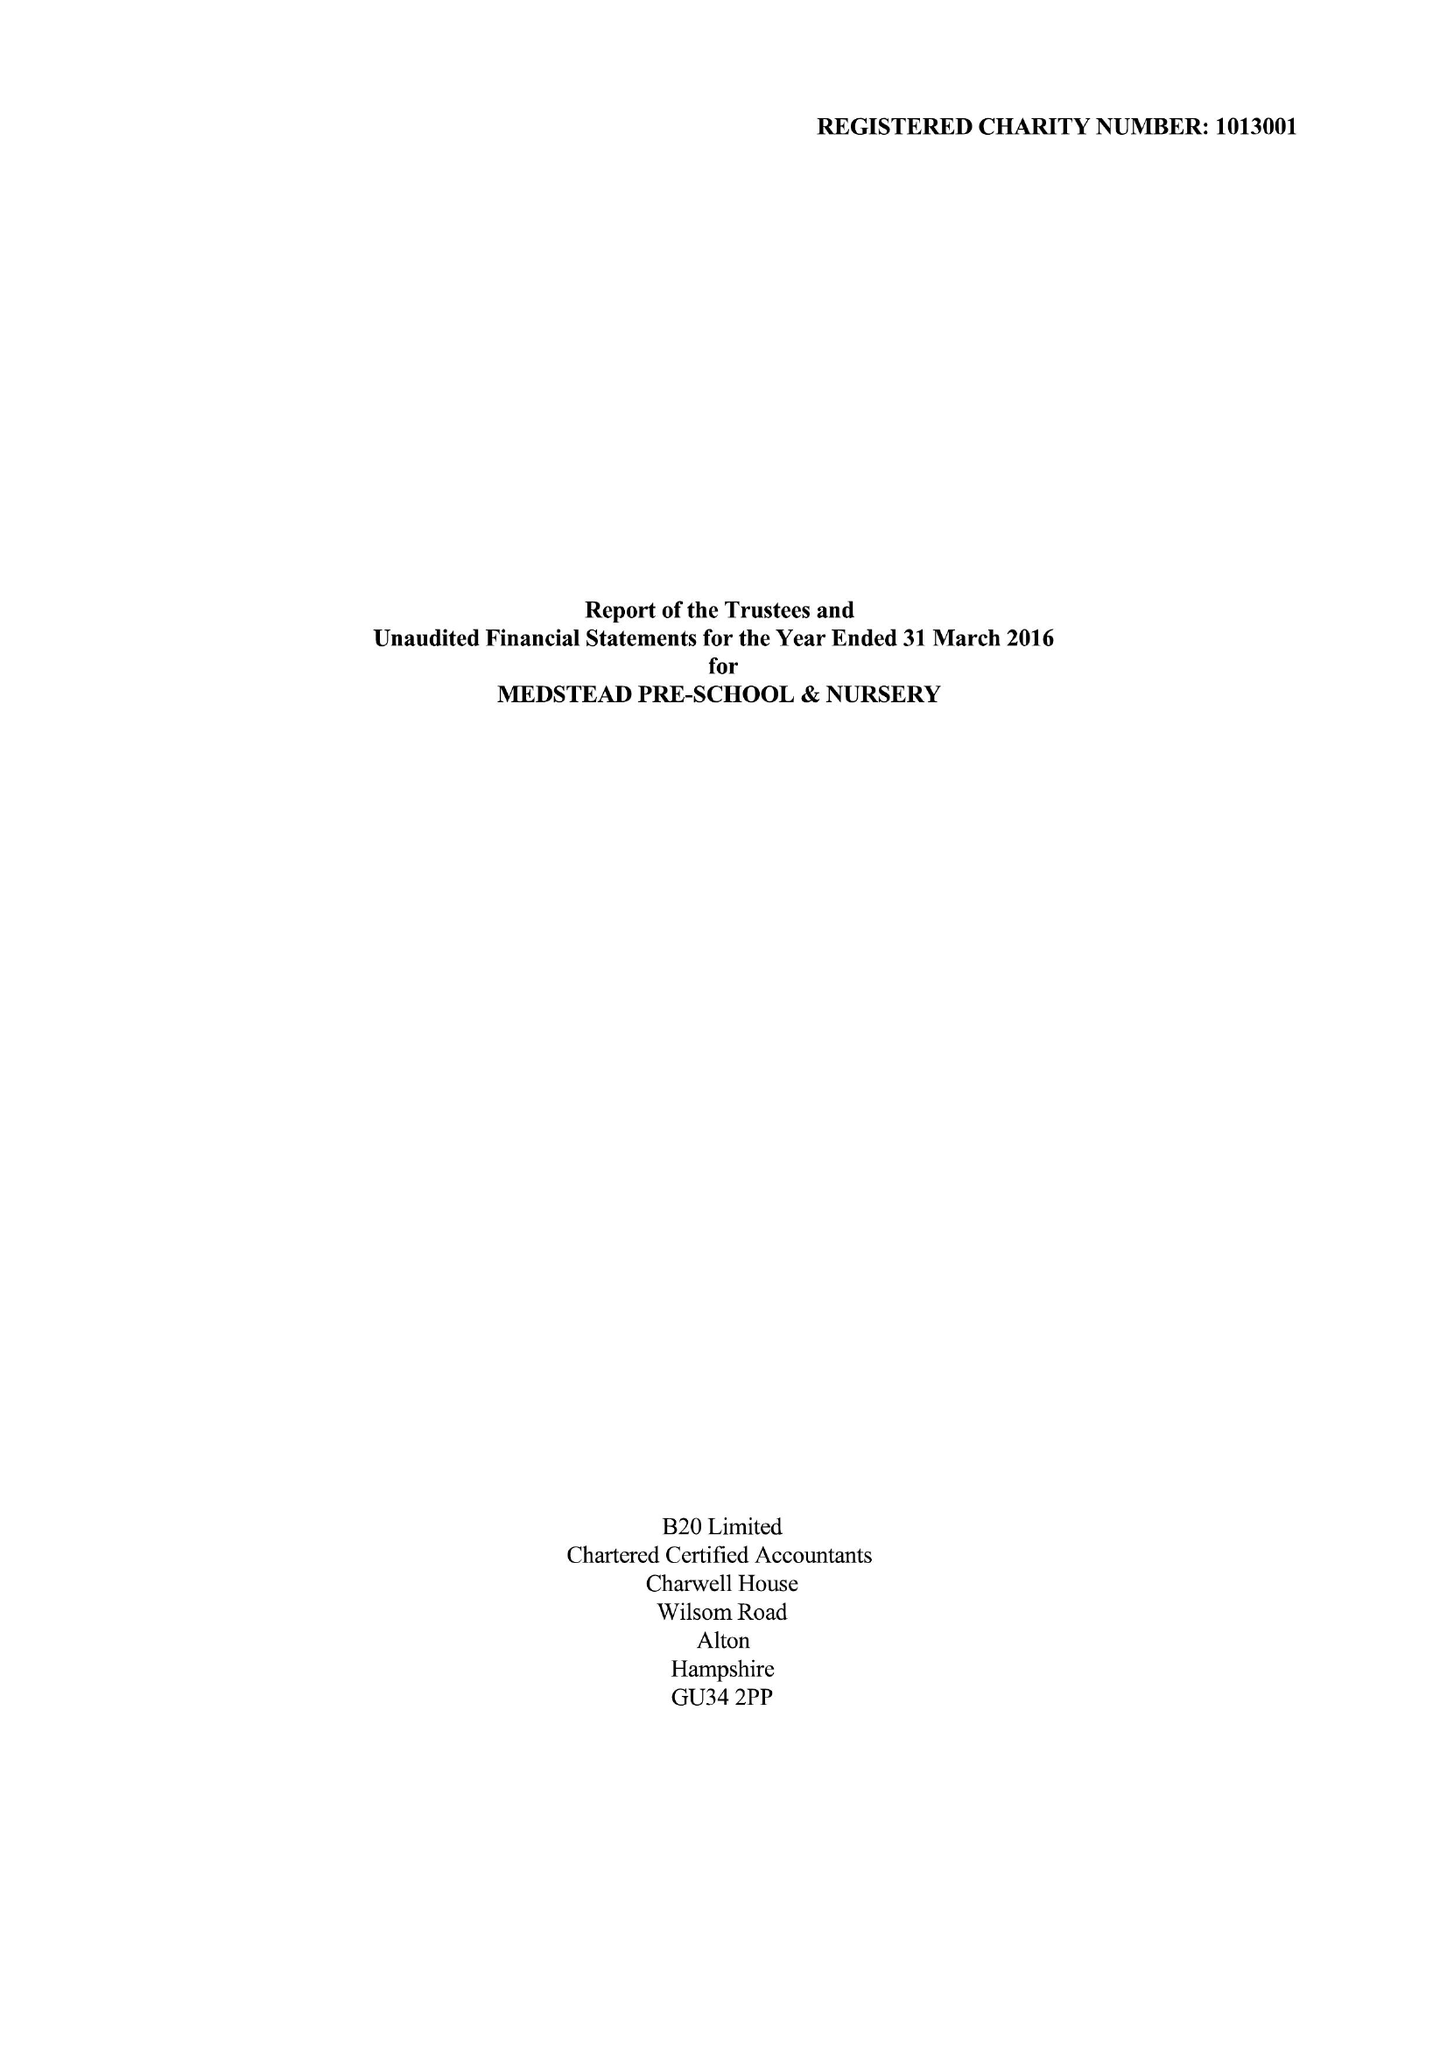What is the value for the address__post_town?
Answer the question using a single word or phrase. ALTON 